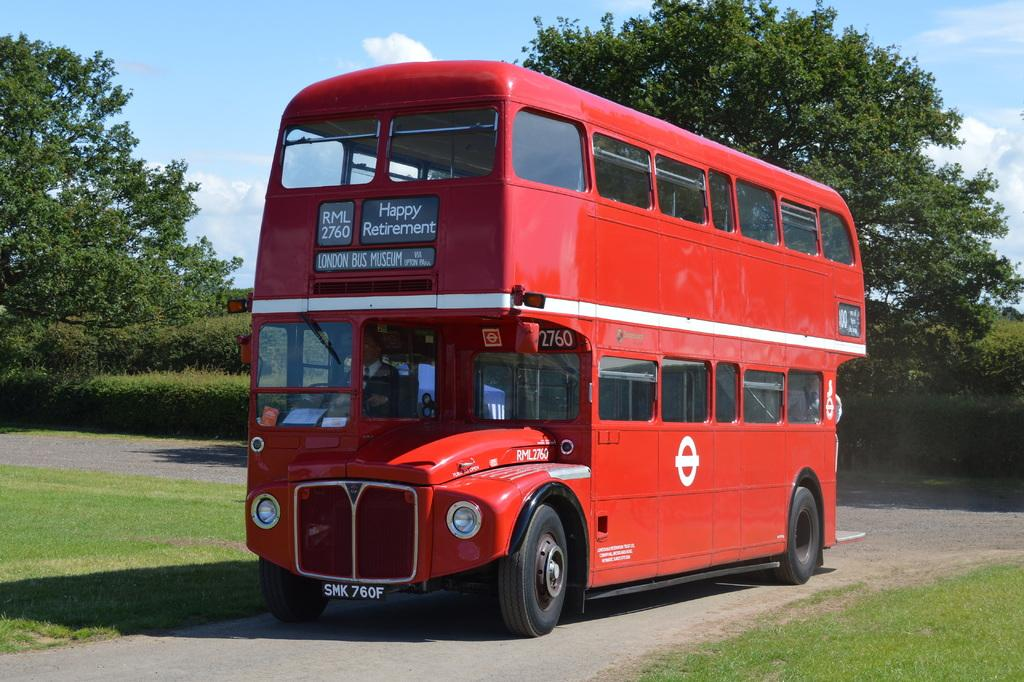<image>
Summarize the visual content of the image. A red bus that says Happy Retirement on its display. 